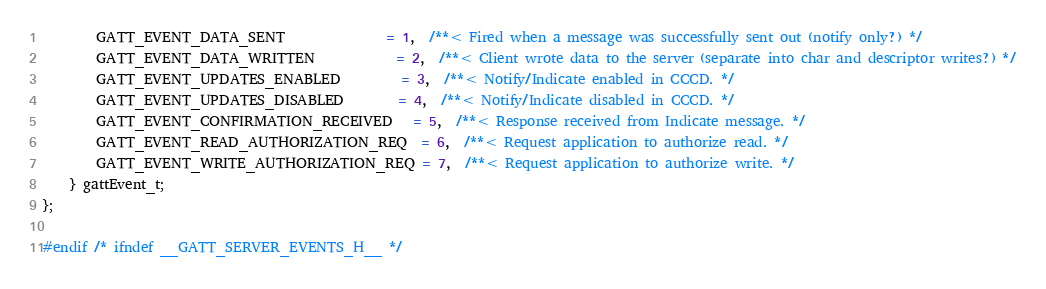Convert code to text. <code><loc_0><loc_0><loc_500><loc_500><_C_>        GATT_EVENT_DATA_SENT               = 1,  /**< Fired when a message was successfully sent out (notify only?) */
        GATT_EVENT_DATA_WRITTEN            = 2,  /**< Client wrote data to the server (separate into char and descriptor writes?) */
        GATT_EVENT_UPDATES_ENABLED         = 3,  /**< Notify/Indicate enabled in CCCD. */
        GATT_EVENT_UPDATES_DISABLED        = 4,  /**< Notify/Indicate disabled in CCCD. */
        GATT_EVENT_CONFIRMATION_RECEIVED   = 5,  /**< Response received from Indicate message. */
        GATT_EVENT_READ_AUTHORIZATION_REQ  = 6,  /**< Request application to authorize read. */
        GATT_EVENT_WRITE_AUTHORIZATION_REQ = 7,  /**< Request application to authorize write. */
    } gattEvent_t;
};

#endif /* ifndef __GATT_SERVER_EVENTS_H__ */</code> 